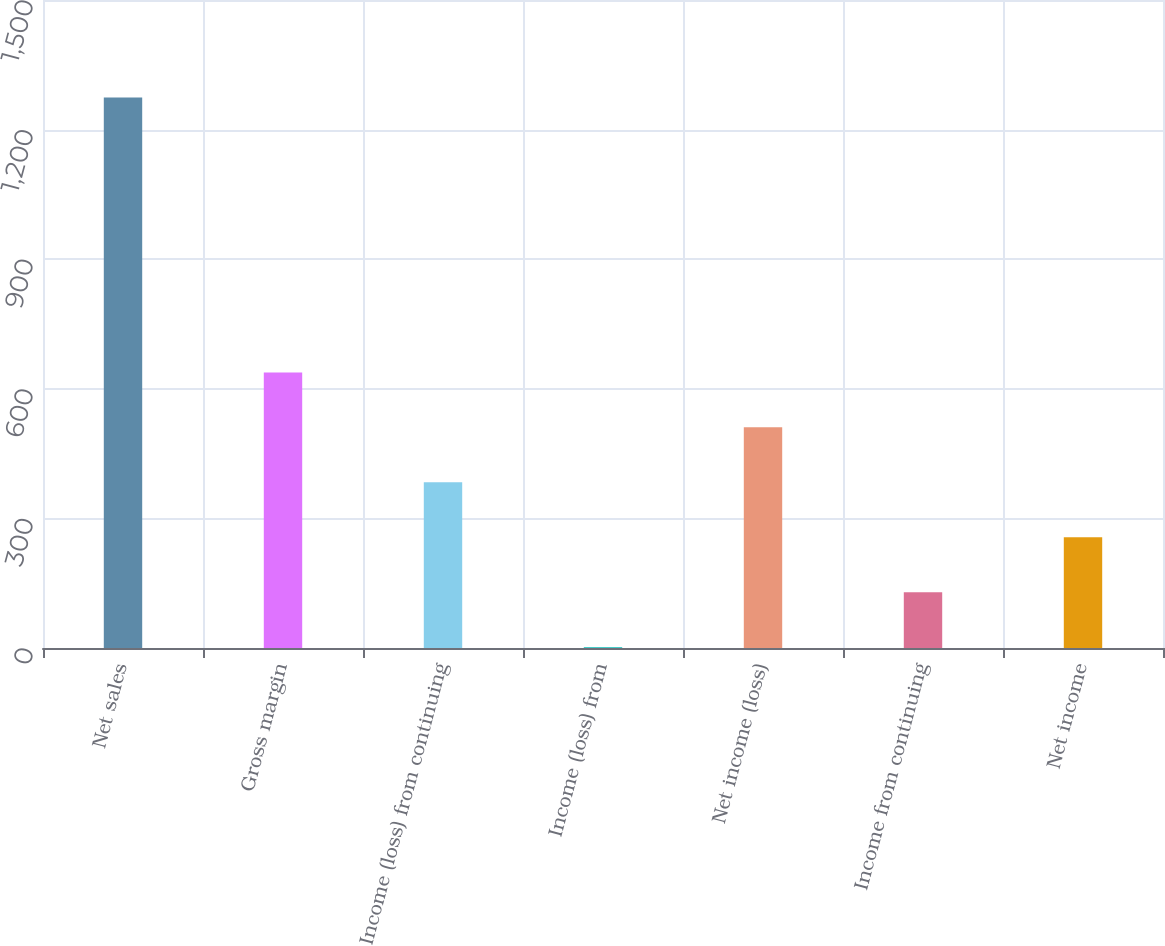Convert chart. <chart><loc_0><loc_0><loc_500><loc_500><bar_chart><fcel>Net sales<fcel>Gross margin<fcel>Income (loss) from continuing<fcel>Income (loss) from<fcel>Net income (loss)<fcel>Income from continuing<fcel>Net income<nl><fcel>1274.2<fcel>638<fcel>383.52<fcel>1.8<fcel>510.76<fcel>129.04<fcel>256.28<nl></chart> 